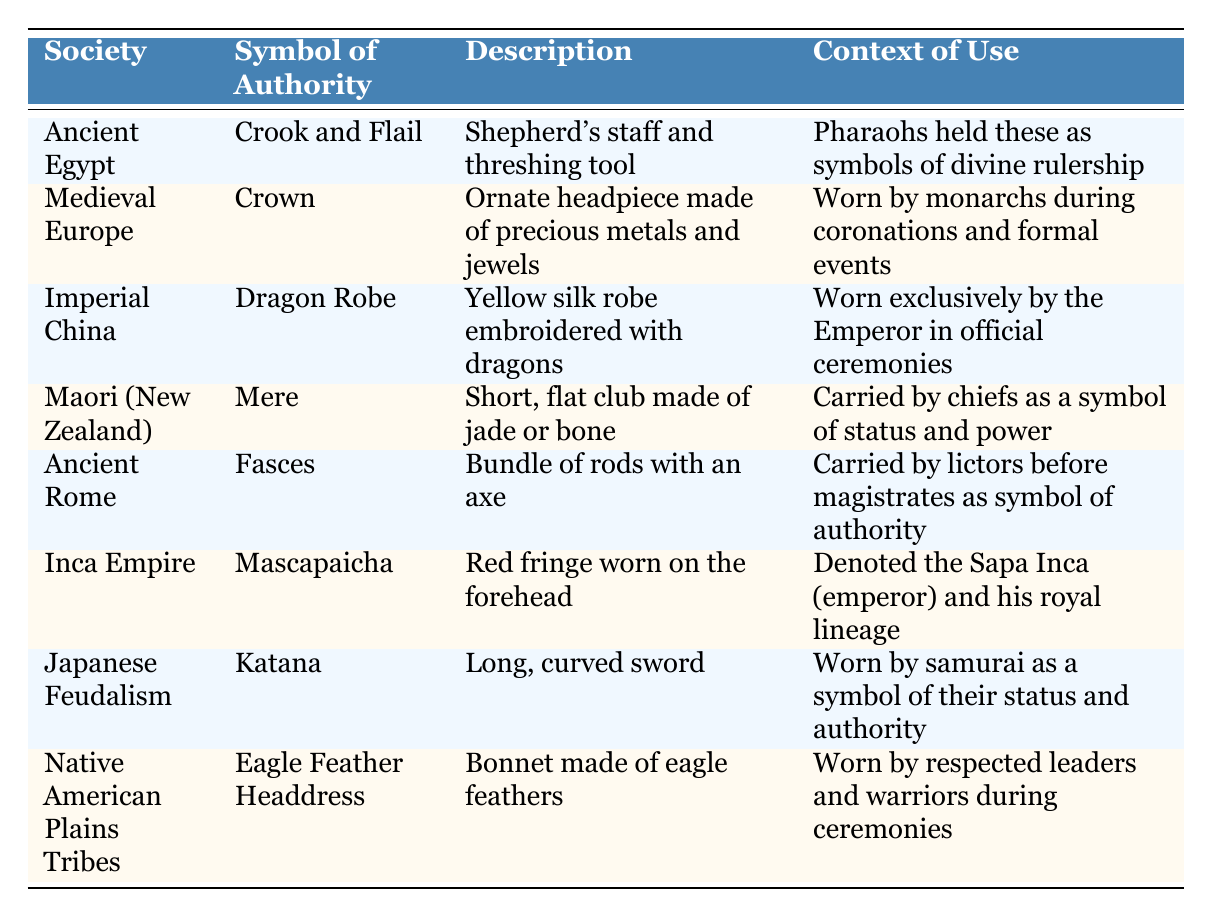What symbol of authority is associated with Ancient Rome? The table shows that the symbol of authority for Ancient Rome is the "Fasces," which is described as a bundle of rods with an axe.
Answer: Fasces Which society used a long, curved sword as a symbol of authority? The table indicates that the "Katana," a long, curved sword, was used as a symbol of authority by the Japanese Feudalism society.
Answer: Japanese Feudalism Is the "Eagle Feather Headdress" worn by warriors during ceremonies in Native American Plains Tribes? According to the table, the "Eagle Feather Headdress" is indeed worn by respected leaders and warriors during ceremonies, making the statement true.
Answer: Yes What is the primary context for wearing the Dragon Robe in Imperial China? The table states that the Dragon Robe is worn exclusively by the Emperor during official ceremonies, which identifies the primary context for its use.
Answer: Official ceremonies What do the symbols of authority in Ancient Egypt and the Inca Empire have in common? Both the Crook and Flail in Ancient Egypt and the Mascapaicha in the Inca Empire serve as symbols of divine or royal status; the Crook and Flail represent divine rulership while the Mascapaicha designates the Sapa Inca’s royal lineage.
Answer: Divine or royal status Which symbols of authority were specifically reserved for leaders (not general society members)? Analyzing the table, the "Crown," "Katana," "Eagle Feather Headdress," and "Mere" are symbols that are reserved for leaders—monarchs, samurai, and chiefs—highlighting their exclusive use by social elites.
Answer: Crown, Katana, Eagle Feather Headdress, Mere 